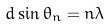Convert formula to latex. <formula><loc_0><loc_0><loc_500><loc_500>d \sin \theta _ { n } = n \lambda</formula> 